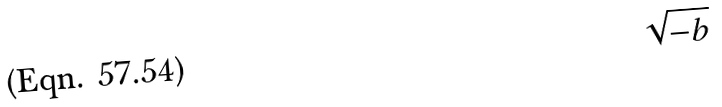Convert formula to latex. <formula><loc_0><loc_0><loc_500><loc_500>\sqrt { - b }</formula> 